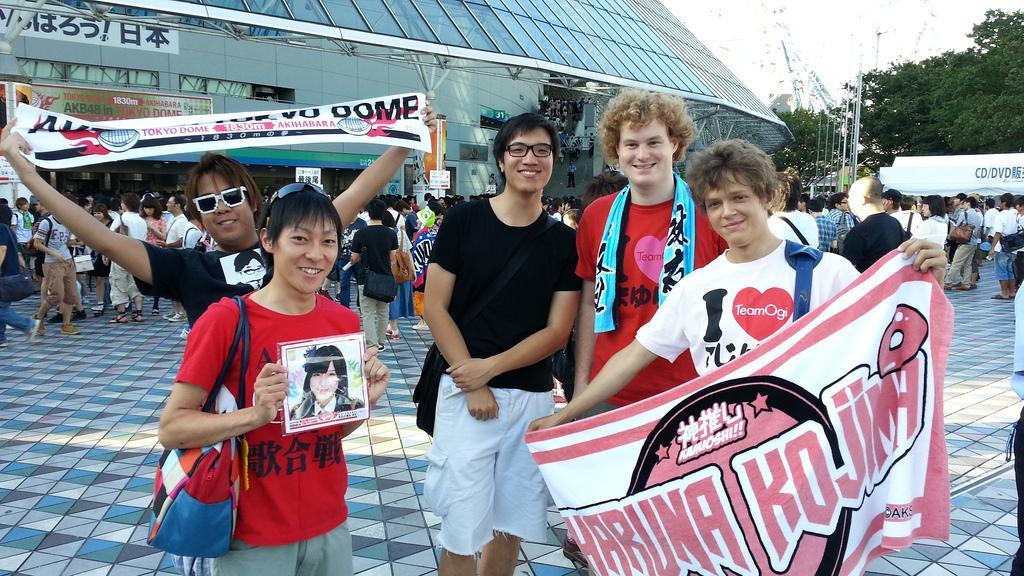How would you summarize this image in a sentence or two? In this image in front there are people holding the banners. Behind them there are a few other people standing on the floor. In the background of the image there are buildings, trees, poles and sky. 